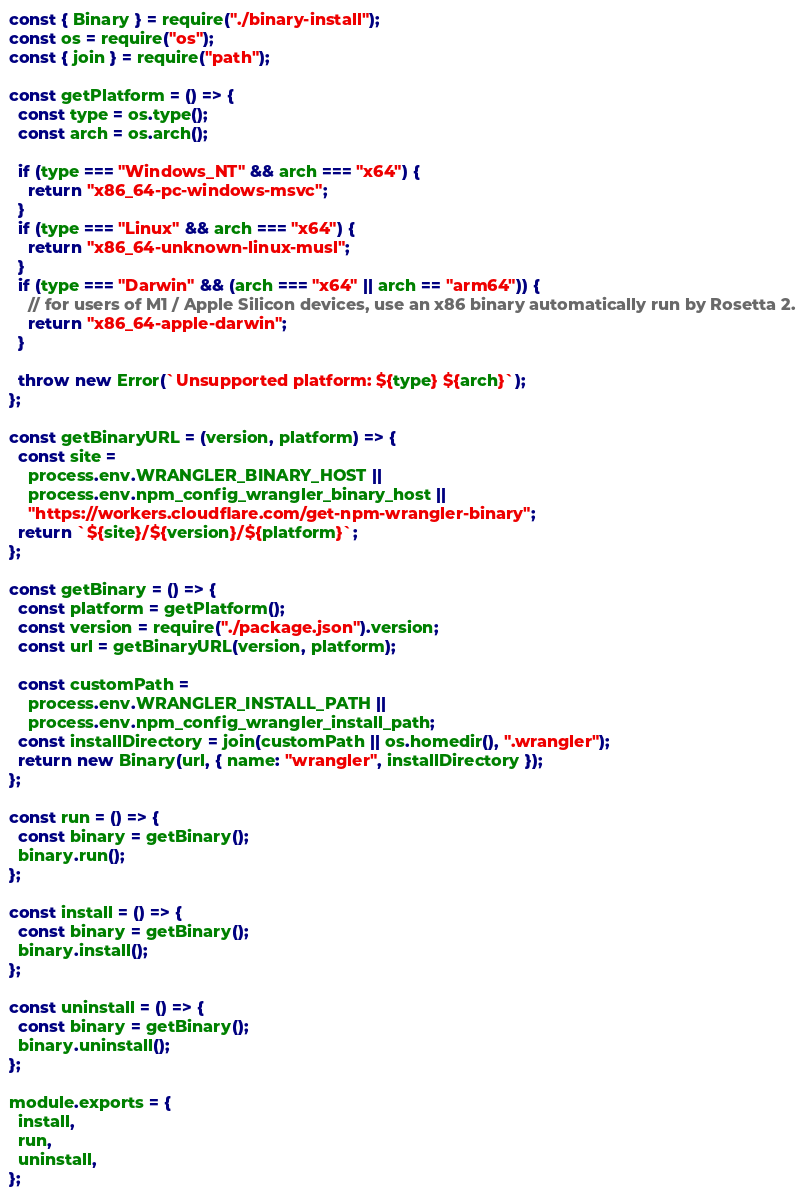<code> <loc_0><loc_0><loc_500><loc_500><_JavaScript_>const { Binary } = require("./binary-install");
const os = require("os");
const { join } = require("path");

const getPlatform = () => {
  const type = os.type();
  const arch = os.arch();

  if (type === "Windows_NT" && arch === "x64") {
    return "x86_64-pc-windows-msvc";
  }
  if (type === "Linux" && arch === "x64") {
    return "x86_64-unknown-linux-musl";
  }
  if (type === "Darwin" && (arch === "x64" || arch == "arm64")) {
    // for users of M1 / Apple Silicon devices, use an x86 binary automatically run by Rosetta 2.
    return "x86_64-apple-darwin";
  }

  throw new Error(`Unsupported platform: ${type} ${arch}`);
};

const getBinaryURL = (version, platform) => {
  const site =
    process.env.WRANGLER_BINARY_HOST ||
    process.env.npm_config_wrangler_binary_host ||
    "https://workers.cloudflare.com/get-npm-wrangler-binary";
  return `${site}/${version}/${platform}`;
};

const getBinary = () => {
  const platform = getPlatform();
  const version = require("./package.json").version;
  const url = getBinaryURL(version, platform);

  const customPath =
    process.env.WRANGLER_INSTALL_PATH ||
    process.env.npm_config_wrangler_install_path;
  const installDirectory = join(customPath || os.homedir(), ".wrangler");
  return new Binary(url, { name: "wrangler", installDirectory });
};

const run = () => {
  const binary = getBinary();
  binary.run();
};

const install = () => {
  const binary = getBinary();
  binary.install();
};

const uninstall = () => {
  const binary = getBinary();
  binary.uninstall();
};

module.exports = {
  install,
  run,
  uninstall,
};</code> 